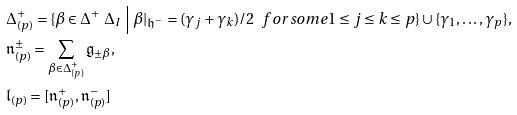<formula> <loc_0><loc_0><loc_500><loc_500>& \Delta _ { ( p ) } ^ { + } = \{ \beta \in \Delta ^ { + } \ \Delta _ { I } \ \Big | \ \beta | _ { \mathfrak { h } ^ { - } } = ( \gamma _ { j } + \gamma _ { k } ) / 2 \ \ f o r s o m e 1 \leq j \leq k \leq p \} \cup \{ \gamma _ { 1 } , \dots , \gamma _ { p } \} , \\ & \mathfrak { n } _ { ( p ) } ^ { \pm } = \sum _ { \beta \in \Delta _ { ( p ) } ^ { + } } \mathfrak { g } _ { \pm \beta } , \\ & \mathfrak { l } _ { ( p ) } = [ \mathfrak { n } _ { ( p ) } ^ { + } , \mathfrak { n } _ { ( p ) } ^ { - } ]</formula> 